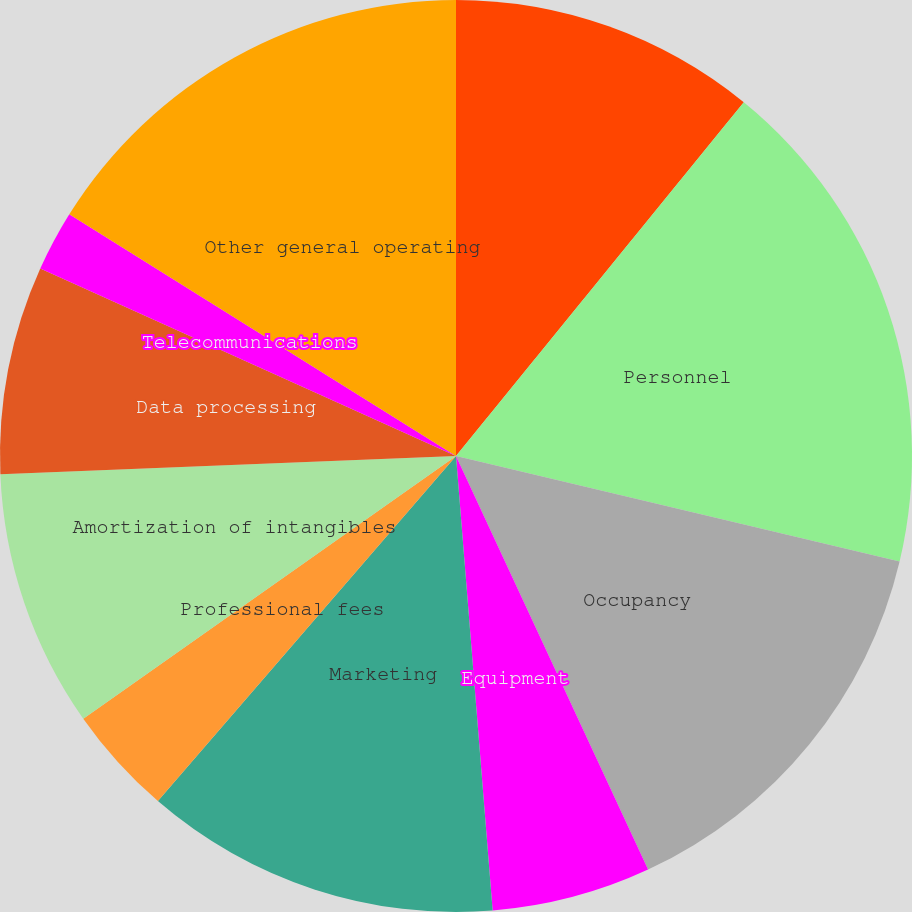Convert chart to OTSL. <chart><loc_0><loc_0><loc_500><loc_500><pie_chart><fcel>(Dollars in millions)<fcel>Personnel<fcel>Occupancy<fcel>Equipment<fcel>Marketing<fcel>Professional fees<fcel>Amortization of intangibles<fcel>Data processing<fcel>Telecommunications<fcel>Other general operating<nl><fcel>10.87%<fcel>17.85%<fcel>14.36%<fcel>5.64%<fcel>12.62%<fcel>3.89%<fcel>9.13%<fcel>7.38%<fcel>2.15%<fcel>16.11%<nl></chart> 